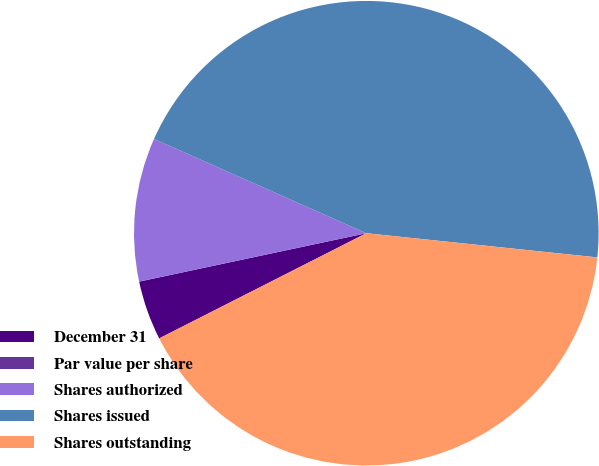Convert chart. <chart><loc_0><loc_0><loc_500><loc_500><pie_chart><fcel>December 31<fcel>Par value per share<fcel>Shares authorized<fcel>Shares issued<fcel>Shares outstanding<nl><fcel>4.14%<fcel>0.0%<fcel>9.99%<fcel>45.01%<fcel>40.86%<nl></chart> 